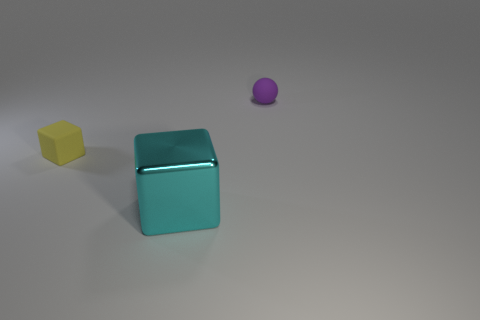Add 3 yellow matte cubes. How many objects exist? 6 Subtract all balls. How many objects are left? 2 Add 2 gray matte cubes. How many gray matte cubes exist? 2 Subtract 0 blue spheres. How many objects are left? 3 Subtract all big brown cubes. Subtract all metallic cubes. How many objects are left? 2 Add 2 big cyan metallic things. How many big cyan metallic things are left? 3 